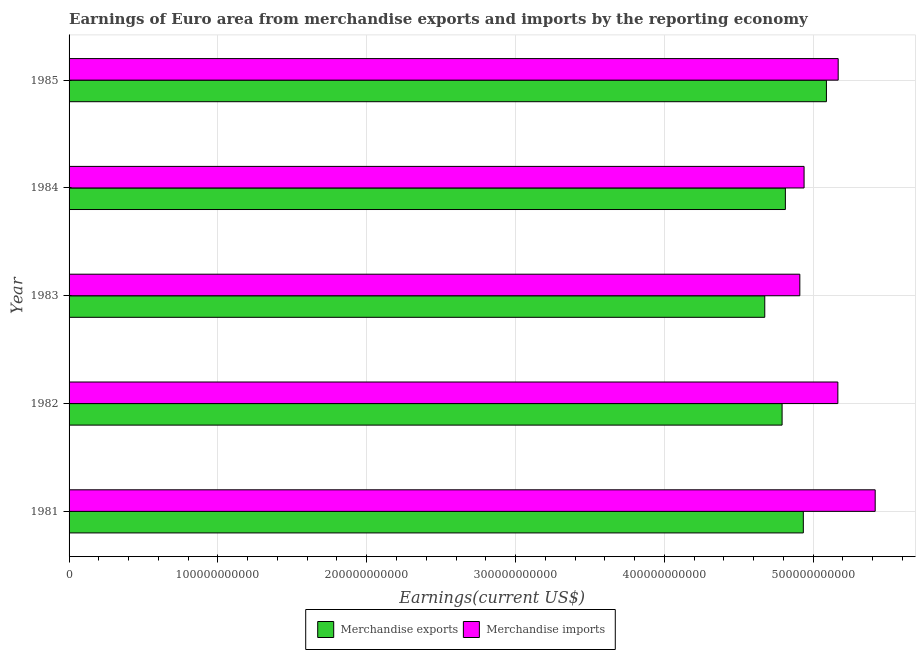How many groups of bars are there?
Your answer should be compact. 5. Are the number of bars per tick equal to the number of legend labels?
Ensure brevity in your answer.  Yes. How many bars are there on the 5th tick from the bottom?
Provide a short and direct response. 2. In how many cases, is the number of bars for a given year not equal to the number of legend labels?
Ensure brevity in your answer.  0. What is the earnings from merchandise imports in 1981?
Your answer should be very brief. 5.42e+11. Across all years, what is the maximum earnings from merchandise imports?
Your answer should be compact. 5.42e+11. Across all years, what is the minimum earnings from merchandise exports?
Your answer should be very brief. 4.67e+11. In which year was the earnings from merchandise exports maximum?
Provide a succinct answer. 1985. What is the total earnings from merchandise exports in the graph?
Your answer should be compact. 2.43e+12. What is the difference between the earnings from merchandise imports in 1982 and that in 1984?
Your response must be concise. 2.27e+1. What is the difference between the earnings from merchandise imports in 1981 and the earnings from merchandise exports in 1982?
Ensure brevity in your answer.  6.25e+1. What is the average earnings from merchandise exports per year?
Provide a short and direct response. 4.86e+11. In the year 1982, what is the difference between the earnings from merchandise imports and earnings from merchandise exports?
Give a very brief answer. 3.75e+1. In how many years, is the earnings from merchandise imports greater than 480000000000 US$?
Your response must be concise. 5. What is the ratio of the earnings from merchandise imports in 1981 to that in 1983?
Your answer should be very brief. 1.1. Is the difference between the earnings from merchandise exports in 1981 and 1985 greater than the difference between the earnings from merchandise imports in 1981 and 1985?
Keep it short and to the point. No. What is the difference between the highest and the second highest earnings from merchandise imports?
Offer a very short reply. 2.49e+1. What is the difference between the highest and the lowest earnings from merchandise exports?
Offer a very short reply. 4.14e+1. In how many years, is the earnings from merchandise imports greater than the average earnings from merchandise imports taken over all years?
Make the answer very short. 3. Is the sum of the earnings from merchandise exports in 1982 and 1984 greater than the maximum earnings from merchandise imports across all years?
Your answer should be very brief. Yes. How many years are there in the graph?
Your response must be concise. 5. What is the difference between two consecutive major ticks on the X-axis?
Make the answer very short. 1.00e+11. Does the graph contain any zero values?
Your answer should be compact. No. Does the graph contain grids?
Your response must be concise. Yes. How are the legend labels stacked?
Offer a terse response. Horizontal. What is the title of the graph?
Offer a terse response. Earnings of Euro area from merchandise exports and imports by the reporting economy. Does "Age 65(male)" appear as one of the legend labels in the graph?
Your response must be concise. No. What is the label or title of the X-axis?
Give a very brief answer. Earnings(current US$). What is the label or title of the Y-axis?
Ensure brevity in your answer.  Year. What is the Earnings(current US$) of Merchandise exports in 1981?
Provide a short and direct response. 4.93e+11. What is the Earnings(current US$) in Merchandise imports in 1981?
Provide a short and direct response. 5.42e+11. What is the Earnings(current US$) of Merchandise exports in 1982?
Make the answer very short. 4.79e+11. What is the Earnings(current US$) of Merchandise imports in 1982?
Your response must be concise. 5.17e+11. What is the Earnings(current US$) in Merchandise exports in 1983?
Provide a succinct answer. 4.67e+11. What is the Earnings(current US$) of Merchandise imports in 1983?
Offer a terse response. 4.91e+11. What is the Earnings(current US$) of Merchandise exports in 1984?
Keep it short and to the point. 4.81e+11. What is the Earnings(current US$) of Merchandise imports in 1984?
Your response must be concise. 4.94e+11. What is the Earnings(current US$) of Merchandise exports in 1985?
Keep it short and to the point. 5.09e+11. What is the Earnings(current US$) in Merchandise imports in 1985?
Your answer should be compact. 5.17e+11. Across all years, what is the maximum Earnings(current US$) in Merchandise exports?
Give a very brief answer. 5.09e+11. Across all years, what is the maximum Earnings(current US$) of Merchandise imports?
Make the answer very short. 5.42e+11. Across all years, what is the minimum Earnings(current US$) of Merchandise exports?
Offer a very short reply. 4.67e+11. Across all years, what is the minimum Earnings(current US$) of Merchandise imports?
Your answer should be very brief. 4.91e+11. What is the total Earnings(current US$) in Merchandise exports in the graph?
Give a very brief answer. 2.43e+12. What is the total Earnings(current US$) in Merchandise imports in the graph?
Give a very brief answer. 2.56e+12. What is the difference between the Earnings(current US$) in Merchandise exports in 1981 and that in 1982?
Ensure brevity in your answer.  1.43e+1. What is the difference between the Earnings(current US$) of Merchandise imports in 1981 and that in 1982?
Give a very brief answer. 2.51e+1. What is the difference between the Earnings(current US$) of Merchandise exports in 1981 and that in 1983?
Your response must be concise. 2.59e+1. What is the difference between the Earnings(current US$) in Merchandise imports in 1981 and that in 1983?
Provide a short and direct response. 5.06e+1. What is the difference between the Earnings(current US$) of Merchandise exports in 1981 and that in 1984?
Ensure brevity in your answer.  1.21e+1. What is the difference between the Earnings(current US$) in Merchandise imports in 1981 and that in 1984?
Offer a terse response. 4.78e+1. What is the difference between the Earnings(current US$) in Merchandise exports in 1981 and that in 1985?
Your answer should be compact. -1.55e+1. What is the difference between the Earnings(current US$) of Merchandise imports in 1981 and that in 1985?
Provide a succinct answer. 2.49e+1. What is the difference between the Earnings(current US$) of Merchandise exports in 1982 and that in 1983?
Offer a very short reply. 1.16e+1. What is the difference between the Earnings(current US$) of Merchandise imports in 1982 and that in 1983?
Provide a succinct answer. 2.56e+1. What is the difference between the Earnings(current US$) of Merchandise exports in 1982 and that in 1984?
Provide a short and direct response. -2.20e+09. What is the difference between the Earnings(current US$) in Merchandise imports in 1982 and that in 1984?
Ensure brevity in your answer.  2.27e+1. What is the difference between the Earnings(current US$) in Merchandise exports in 1982 and that in 1985?
Offer a terse response. -2.98e+1. What is the difference between the Earnings(current US$) in Merchandise imports in 1982 and that in 1985?
Provide a succinct answer. -2.18e+08. What is the difference between the Earnings(current US$) in Merchandise exports in 1983 and that in 1984?
Your response must be concise. -1.38e+1. What is the difference between the Earnings(current US$) of Merchandise imports in 1983 and that in 1984?
Your answer should be compact. -2.85e+09. What is the difference between the Earnings(current US$) in Merchandise exports in 1983 and that in 1985?
Your answer should be very brief. -4.14e+1. What is the difference between the Earnings(current US$) of Merchandise imports in 1983 and that in 1985?
Ensure brevity in your answer.  -2.58e+1. What is the difference between the Earnings(current US$) of Merchandise exports in 1984 and that in 1985?
Give a very brief answer. -2.76e+1. What is the difference between the Earnings(current US$) in Merchandise imports in 1984 and that in 1985?
Provide a short and direct response. -2.29e+1. What is the difference between the Earnings(current US$) in Merchandise exports in 1981 and the Earnings(current US$) in Merchandise imports in 1982?
Make the answer very short. -2.32e+1. What is the difference between the Earnings(current US$) in Merchandise exports in 1981 and the Earnings(current US$) in Merchandise imports in 1983?
Provide a short and direct response. 2.34e+09. What is the difference between the Earnings(current US$) of Merchandise exports in 1981 and the Earnings(current US$) of Merchandise imports in 1984?
Provide a succinct answer. -5.07e+08. What is the difference between the Earnings(current US$) of Merchandise exports in 1981 and the Earnings(current US$) of Merchandise imports in 1985?
Provide a short and direct response. -2.34e+1. What is the difference between the Earnings(current US$) in Merchandise exports in 1982 and the Earnings(current US$) in Merchandise imports in 1983?
Provide a succinct answer. -1.19e+1. What is the difference between the Earnings(current US$) in Merchandise exports in 1982 and the Earnings(current US$) in Merchandise imports in 1984?
Provide a short and direct response. -1.48e+1. What is the difference between the Earnings(current US$) of Merchandise exports in 1982 and the Earnings(current US$) of Merchandise imports in 1985?
Offer a terse response. -3.77e+1. What is the difference between the Earnings(current US$) in Merchandise exports in 1983 and the Earnings(current US$) in Merchandise imports in 1984?
Your answer should be very brief. -2.64e+1. What is the difference between the Earnings(current US$) in Merchandise exports in 1983 and the Earnings(current US$) in Merchandise imports in 1985?
Ensure brevity in your answer.  -4.93e+1. What is the difference between the Earnings(current US$) of Merchandise exports in 1984 and the Earnings(current US$) of Merchandise imports in 1985?
Offer a very short reply. -3.55e+1. What is the average Earnings(current US$) of Merchandise exports per year?
Your response must be concise. 4.86e+11. What is the average Earnings(current US$) in Merchandise imports per year?
Offer a very short reply. 5.12e+11. In the year 1981, what is the difference between the Earnings(current US$) in Merchandise exports and Earnings(current US$) in Merchandise imports?
Offer a very short reply. -4.83e+1. In the year 1982, what is the difference between the Earnings(current US$) of Merchandise exports and Earnings(current US$) of Merchandise imports?
Your answer should be compact. -3.75e+1. In the year 1983, what is the difference between the Earnings(current US$) of Merchandise exports and Earnings(current US$) of Merchandise imports?
Offer a terse response. -2.36e+1. In the year 1984, what is the difference between the Earnings(current US$) of Merchandise exports and Earnings(current US$) of Merchandise imports?
Your answer should be compact. -1.26e+1. In the year 1985, what is the difference between the Earnings(current US$) of Merchandise exports and Earnings(current US$) of Merchandise imports?
Give a very brief answer. -7.91e+09. What is the ratio of the Earnings(current US$) of Merchandise exports in 1981 to that in 1982?
Provide a short and direct response. 1.03. What is the ratio of the Earnings(current US$) in Merchandise imports in 1981 to that in 1982?
Ensure brevity in your answer.  1.05. What is the ratio of the Earnings(current US$) in Merchandise exports in 1981 to that in 1983?
Provide a short and direct response. 1.06. What is the ratio of the Earnings(current US$) of Merchandise imports in 1981 to that in 1983?
Offer a very short reply. 1.1. What is the ratio of the Earnings(current US$) of Merchandise exports in 1981 to that in 1984?
Provide a succinct answer. 1.03. What is the ratio of the Earnings(current US$) of Merchandise imports in 1981 to that in 1984?
Your response must be concise. 1.1. What is the ratio of the Earnings(current US$) of Merchandise exports in 1981 to that in 1985?
Your response must be concise. 0.97. What is the ratio of the Earnings(current US$) of Merchandise imports in 1981 to that in 1985?
Give a very brief answer. 1.05. What is the ratio of the Earnings(current US$) of Merchandise exports in 1982 to that in 1983?
Provide a succinct answer. 1.02. What is the ratio of the Earnings(current US$) in Merchandise imports in 1982 to that in 1983?
Make the answer very short. 1.05. What is the ratio of the Earnings(current US$) in Merchandise exports in 1982 to that in 1984?
Offer a very short reply. 1. What is the ratio of the Earnings(current US$) in Merchandise imports in 1982 to that in 1984?
Your response must be concise. 1.05. What is the ratio of the Earnings(current US$) of Merchandise exports in 1982 to that in 1985?
Provide a succinct answer. 0.94. What is the ratio of the Earnings(current US$) in Merchandise imports in 1982 to that in 1985?
Your answer should be compact. 1. What is the ratio of the Earnings(current US$) in Merchandise exports in 1983 to that in 1984?
Give a very brief answer. 0.97. What is the ratio of the Earnings(current US$) in Merchandise exports in 1983 to that in 1985?
Ensure brevity in your answer.  0.92. What is the ratio of the Earnings(current US$) of Merchandise imports in 1983 to that in 1985?
Give a very brief answer. 0.95. What is the ratio of the Earnings(current US$) in Merchandise exports in 1984 to that in 1985?
Provide a succinct answer. 0.95. What is the ratio of the Earnings(current US$) in Merchandise imports in 1984 to that in 1985?
Your answer should be compact. 0.96. What is the difference between the highest and the second highest Earnings(current US$) of Merchandise exports?
Your answer should be very brief. 1.55e+1. What is the difference between the highest and the second highest Earnings(current US$) in Merchandise imports?
Give a very brief answer. 2.49e+1. What is the difference between the highest and the lowest Earnings(current US$) in Merchandise exports?
Make the answer very short. 4.14e+1. What is the difference between the highest and the lowest Earnings(current US$) of Merchandise imports?
Keep it short and to the point. 5.06e+1. 